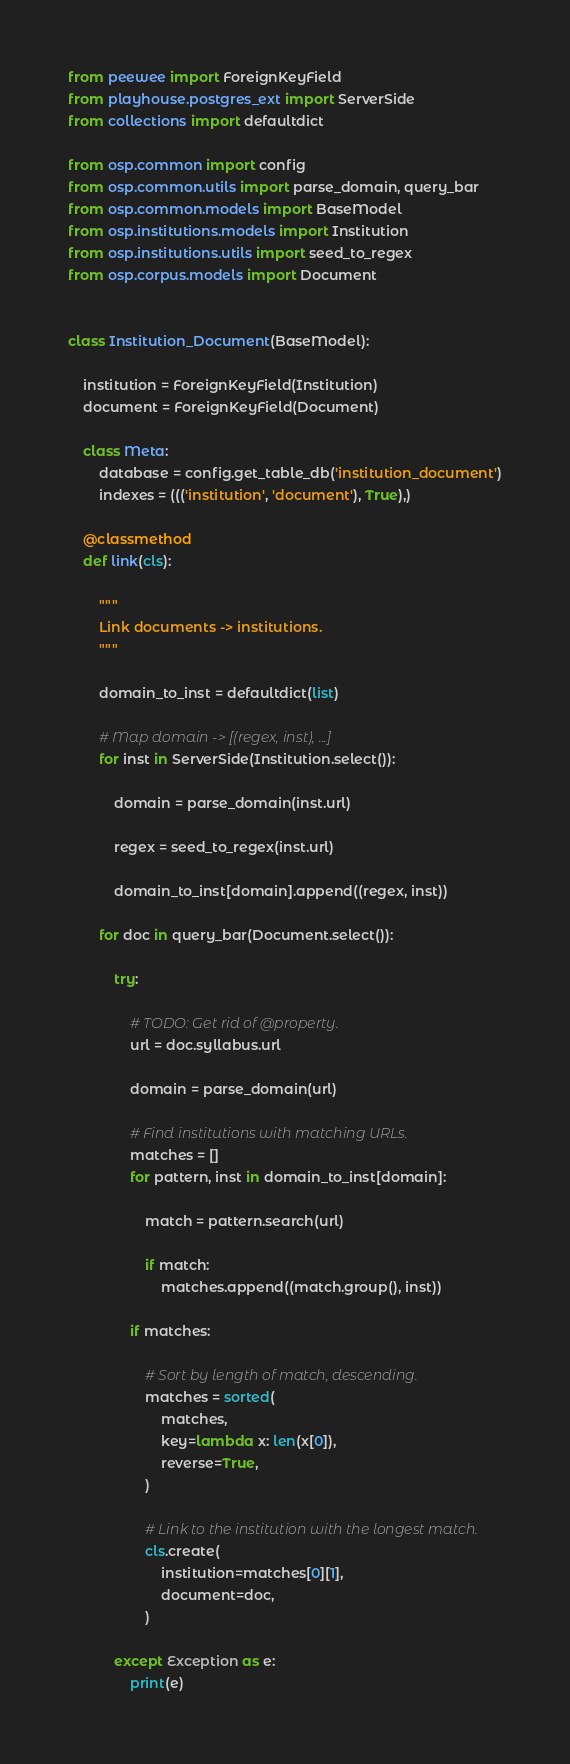Convert code to text. <code><loc_0><loc_0><loc_500><loc_500><_Python_>

from peewee import ForeignKeyField
from playhouse.postgres_ext import ServerSide
from collections import defaultdict

from osp.common import config
from osp.common.utils import parse_domain, query_bar
from osp.common.models import BaseModel
from osp.institutions.models import Institution
from osp.institutions.utils import seed_to_regex
from osp.corpus.models import Document


class Institution_Document(BaseModel):

    institution = ForeignKeyField(Institution)
    document = ForeignKeyField(Document)

    class Meta:
        database = config.get_table_db('institution_document')
        indexes = ((('institution', 'document'), True),)

    @classmethod
    def link(cls):

        """
        Link documents -> institutions.
        """

        domain_to_inst = defaultdict(list)

        # Map domain -> [(regex, inst), ...]
        for inst in ServerSide(Institution.select()):

            domain = parse_domain(inst.url)

            regex = seed_to_regex(inst.url)

            domain_to_inst[domain].append((regex, inst))

        for doc in query_bar(Document.select()):

            try:

                # TODO: Get rid of @property.
                url = doc.syllabus.url

                domain = parse_domain(url)

                # Find institutions with matching URLs.
                matches = []
                for pattern, inst in domain_to_inst[domain]:

                    match = pattern.search(url)

                    if match:
                        matches.append((match.group(), inst))

                if matches:

                    # Sort by length of match, descending.
                    matches = sorted(
                        matches,
                        key=lambda x: len(x[0]),
                        reverse=True,
                    )

                    # Link to the institution with the longest match.
                    cls.create(
                        institution=matches[0][1],
                        document=doc,
                    )

            except Exception as e:
                print(e)
</code> 